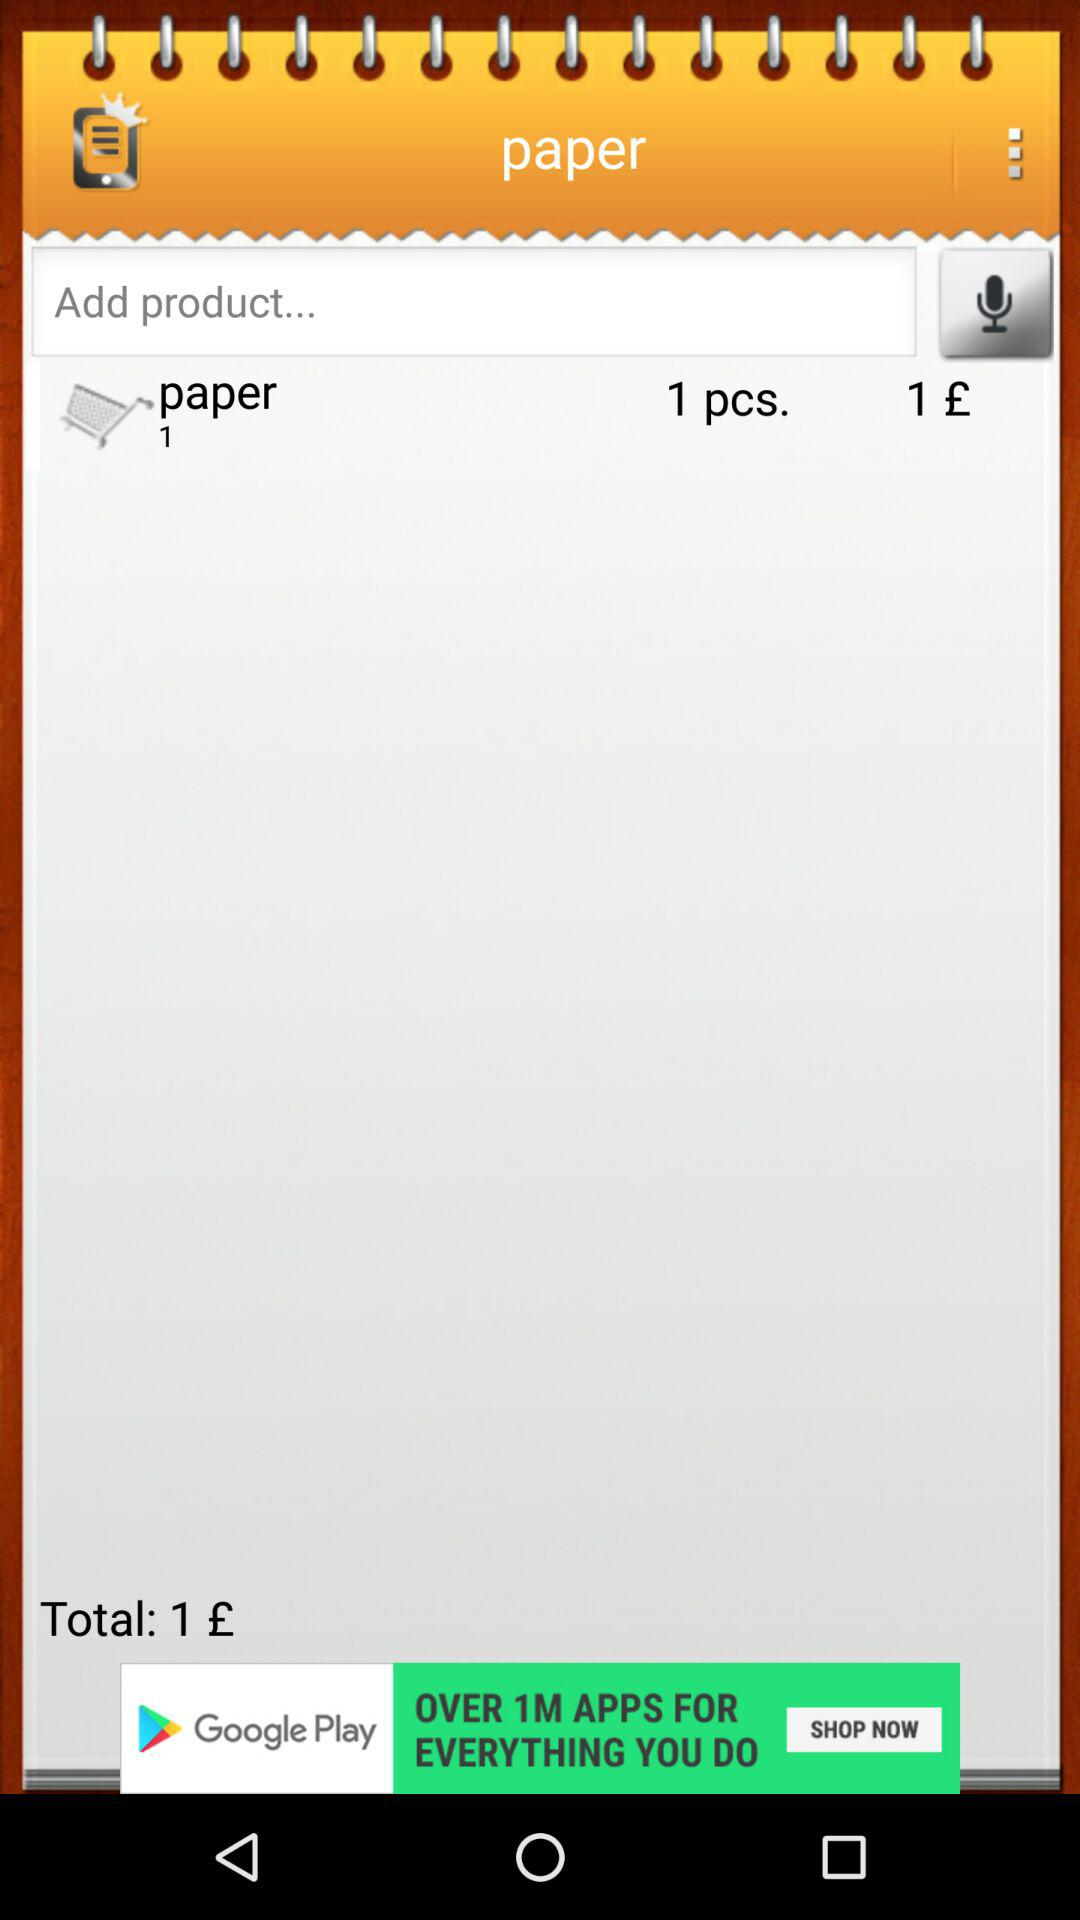What is the total price? The total price is £1. 